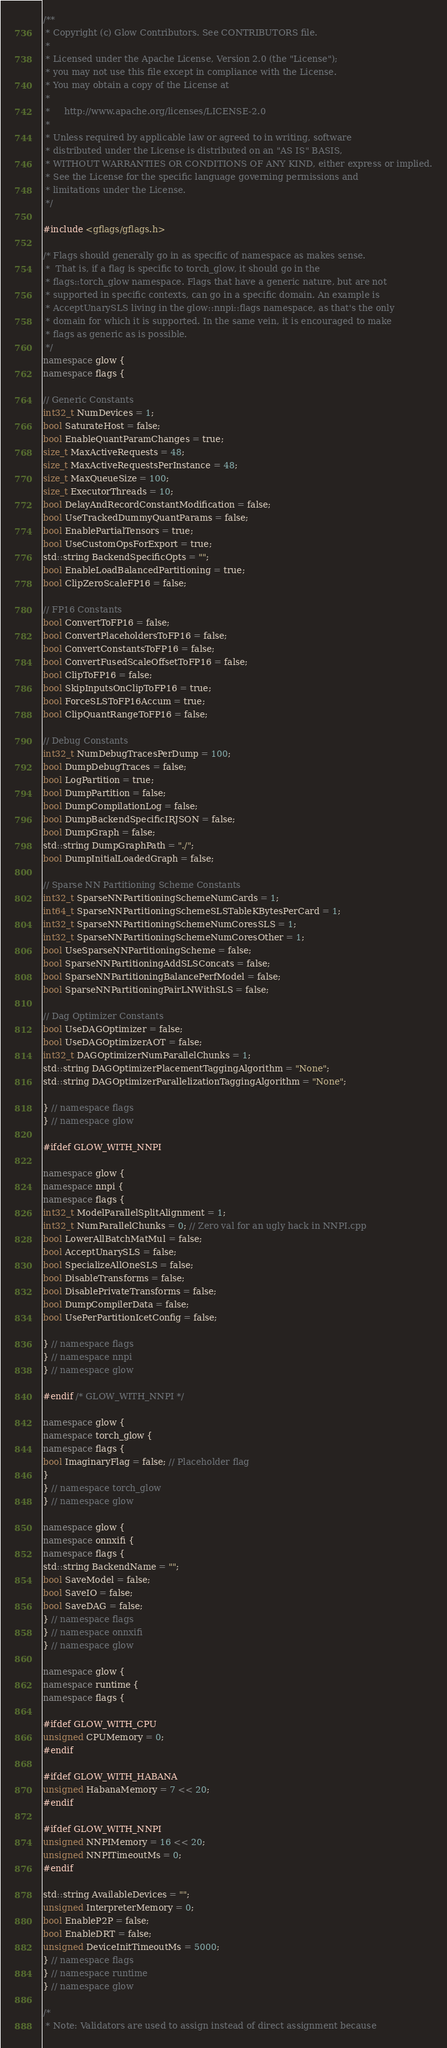<code> <loc_0><loc_0><loc_500><loc_500><_C++_>/**
 * Copyright (c) Glow Contributors. See CONTRIBUTORS file.
 *
 * Licensed under the Apache License, Version 2.0 (the "License");
 * you may not use this file except in compliance with the License.
 * You may obtain a copy of the License at
 *
 *     http://www.apache.org/licenses/LICENSE-2.0
 *
 * Unless required by applicable law or agreed to in writing, software
 * distributed under the License is distributed on an "AS IS" BASIS,
 * WITHOUT WARRANTIES OR CONDITIONS OF ANY KIND, either express or implied.
 * See the License for the specific language governing permissions and
 * limitations under the License.
 */

#include <gflags/gflags.h>

/* Flags should generally go in as specific of namespace as makes sense.
 *  That is, if a flag is specific to torch_glow, it should go in the
 * flags::torch_glow namespace. Flags that have a generic nature, but are not
 * supported in specific contexts, can go in a specific domain. An example is
 * AcceptUnarySLS living in the glow::nnpi::flags namespace, as that's the only
 * domain for which it is supported. In the same vein, it is encouraged to make
 * flags as generic as is possible.
 */
namespace glow {
namespace flags {

// Generic Constants
int32_t NumDevices = 1;
bool SaturateHost = false;
bool EnableQuantParamChanges = true;
size_t MaxActiveRequests = 48;
size_t MaxActiveRequestsPerInstance = 48;
size_t MaxQueueSize = 100;
size_t ExecutorThreads = 10;
bool DelayAndRecordConstantModification = false;
bool UseTrackedDummyQuantParams = false;
bool EnablePartialTensors = true;
bool UseCustomOpsForExport = true;
std::string BackendSpecificOpts = "";
bool EnableLoadBalancedPartitioning = true;
bool ClipZeroScaleFP16 = false;

// FP16 Constants
bool ConvertToFP16 = false;
bool ConvertPlaceholdersToFP16 = false;
bool ConvertConstantsToFP16 = false;
bool ConvertFusedScaleOffsetToFP16 = false;
bool ClipToFP16 = false;
bool SkipInputsOnClipToFP16 = true;
bool ForceSLSToFP16Accum = true;
bool ClipQuantRangeToFP16 = false;

// Debug Constants
int32_t NumDebugTracesPerDump = 100;
bool DumpDebugTraces = false;
bool LogPartition = true;
bool DumpPartition = false;
bool DumpCompilationLog = false;
bool DumpBackendSpecificIRJSON = false;
bool DumpGraph = false;
std::string DumpGraphPath = "./";
bool DumpInitialLoadedGraph = false;

// Sparse NN Partitioning Scheme Constants
int32_t SparseNNPartitioningSchemeNumCards = 1;
int64_t SparseNNPartitioningSchemeSLSTableKBytesPerCard = 1;
int32_t SparseNNPartitioningSchemeNumCoresSLS = 1;
int32_t SparseNNPartitioningSchemeNumCoresOther = 1;
bool UseSparseNNPartitioningScheme = false;
bool SparseNNPartitioningAddSLSConcats = false;
bool SparseNNPartitioningBalancePerfModel = false;
bool SparseNNPartitioningPairLNWithSLS = false;

// Dag Optimizer Constants
bool UseDAGOptimizer = false;
bool UseDAGOptimizerAOT = false;
int32_t DAGOptimizerNumParallelChunks = 1;
std::string DAGOptimizerPlacementTaggingAlgorithm = "None";
std::string DAGOptimizerParallelizationTaggingAlgorithm = "None";

} // namespace flags
} // namespace glow

#ifdef GLOW_WITH_NNPI

namespace glow {
namespace nnpi {
namespace flags {
int32_t ModelParallelSplitAlignment = 1;
int32_t NumParallelChunks = 0; // Zero val for an ugly hack in NNPI.cpp
bool LowerAllBatchMatMul = false;
bool AcceptUnarySLS = false;
bool SpecializeAllOneSLS = false;
bool DisableTransforms = false;
bool DisablePrivateTransforms = false;
bool DumpCompilerData = false;
bool UsePerPartitionIcetConfig = false;

} // namespace flags
} // namespace nnpi
} // namespace glow

#endif /* GLOW_WITH_NNPI */

namespace glow {
namespace torch_glow {
namespace flags {
bool ImaginaryFlag = false; // Placeholder flag
}
} // namespace torch_glow
} // namespace glow

namespace glow {
namespace onnxifi {
namespace flags {
std::string BackendName = "";
bool SaveModel = false;
bool SaveIO = false;
bool SaveDAG = false;
} // namespace flags
} // namespace onnxifi
} // namespace glow

namespace glow {
namespace runtime {
namespace flags {

#ifdef GLOW_WITH_CPU
unsigned CPUMemory = 0;
#endif

#ifdef GLOW_WITH_HABANA
unsigned HabanaMemory = 7 << 20;
#endif

#ifdef GLOW_WITH_NNPI
unsigned NNPIMemory = 16 << 20;
unsigned NNPITimeoutMs = 0;
#endif

std::string AvailableDevices = "";
unsigned InterpreterMemory = 0;
bool EnableP2P = false;
bool EnableDRT = false;
unsigned DeviceInitTimeoutMs = 5000;
} // namespace flags
} // namespace runtime
} // namespace glow

/*
 * Note: Validators are used to assign instead of direct assignment because</code> 